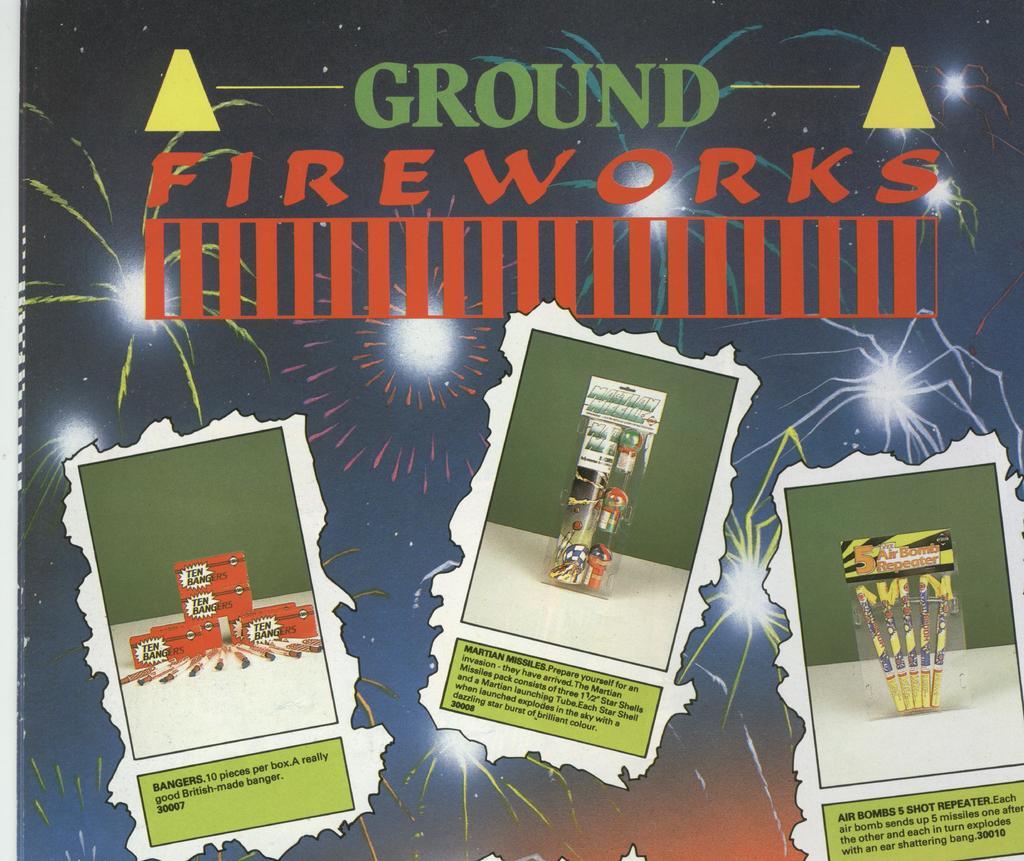What is being advertised?
Give a very brief answer. Fireworks. What word is closest to the top of the page?
Provide a succinct answer. Ground. 